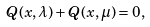Convert formula to latex. <formula><loc_0><loc_0><loc_500><loc_500>Q ( x , \lambda ) + Q ( x , \mu ) = 0 ,</formula> 